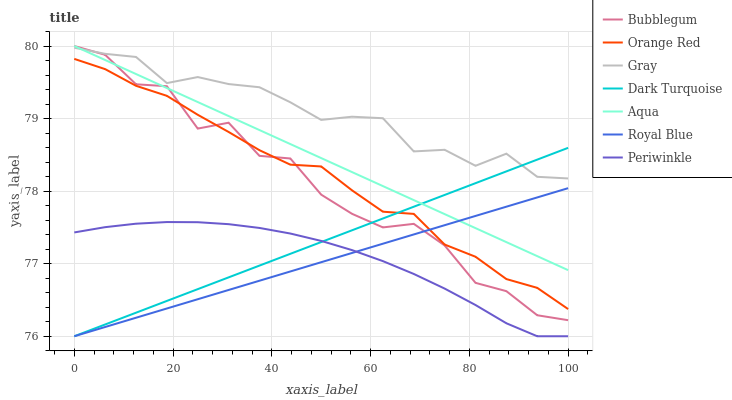Does Dark Turquoise have the minimum area under the curve?
Answer yes or no. No. Does Dark Turquoise have the maximum area under the curve?
Answer yes or no. No. Is Aqua the smoothest?
Answer yes or no. No. Is Aqua the roughest?
Answer yes or no. No. Does Aqua have the lowest value?
Answer yes or no. No. Does Dark Turquoise have the highest value?
Answer yes or no. No. Is Periwinkle less than Orange Red?
Answer yes or no. Yes. Is Aqua greater than Orange Red?
Answer yes or no. Yes. Does Periwinkle intersect Orange Red?
Answer yes or no. No. 